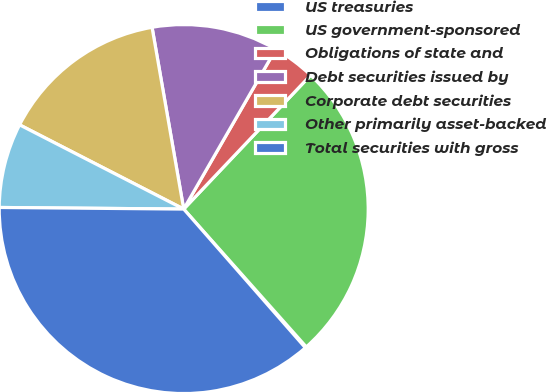Convert chart. <chart><loc_0><loc_0><loc_500><loc_500><pie_chart><fcel>US treasuries<fcel>US government-sponsored<fcel>Obligations of state and<fcel>Debt securities issued by<fcel>Corporate debt securities<fcel>Other primarily asset-backed<fcel>Total securities with gross<nl><fcel>0.11%<fcel>26.36%<fcel>3.76%<fcel>11.06%<fcel>14.71%<fcel>7.41%<fcel>36.6%<nl></chart> 